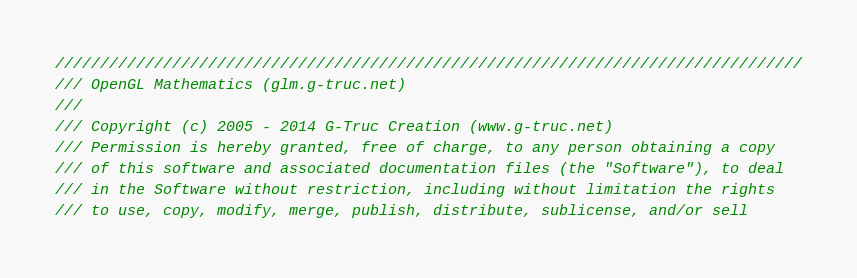Convert code to text. <code><loc_0><loc_0><loc_500><loc_500><_C++_>///////////////////////////////////////////////////////////////////////////////////
/// OpenGL Mathematics (glm.g-truc.net)
///
/// Copyright (c) 2005 - 2014 G-Truc Creation (www.g-truc.net)
/// Permission is hereby granted, free of charge, to any person obtaining a copy
/// of this software and associated documentation files (the "Software"), to deal
/// in the Software without restriction, including without limitation the rights
/// to use, copy, modify, merge, publish, distribute, sublicense, and/or sell</code> 